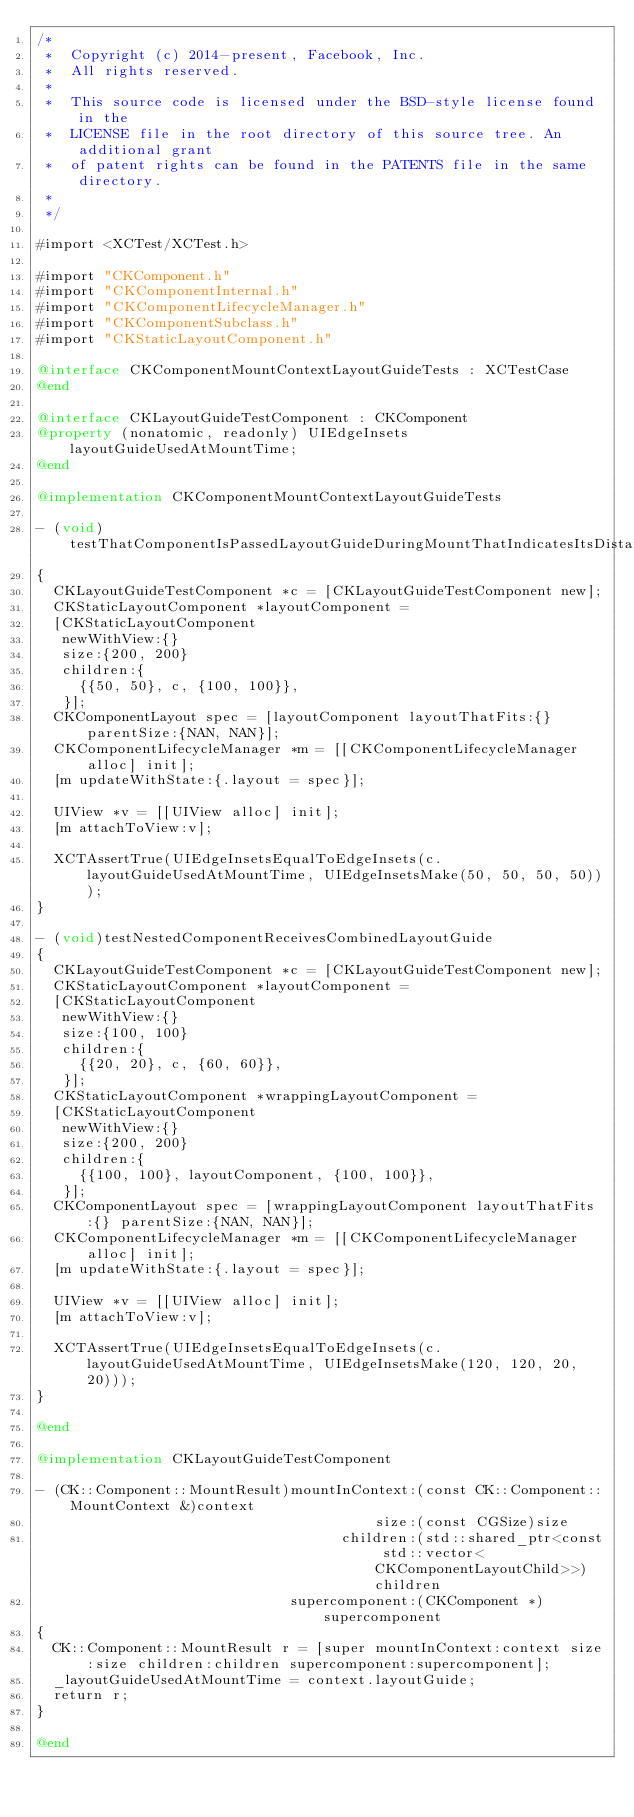<code> <loc_0><loc_0><loc_500><loc_500><_ObjectiveC_>/*
 *  Copyright (c) 2014-present, Facebook, Inc.
 *  All rights reserved.
 *
 *  This source code is licensed under the BSD-style license found in the
 *  LICENSE file in the root directory of this source tree. An additional grant 
 *  of patent rights can be found in the PATENTS file in the same directory.
 *
 */

#import <XCTest/XCTest.h>

#import "CKComponent.h"
#import "CKComponentInternal.h"
#import "CKComponentLifecycleManager.h"
#import "CKComponentSubclass.h"
#import "CKStaticLayoutComponent.h"

@interface CKComponentMountContextLayoutGuideTests : XCTestCase
@end

@interface CKLayoutGuideTestComponent : CKComponent
@property (nonatomic, readonly) UIEdgeInsets layoutGuideUsedAtMountTime;
@end

@implementation CKComponentMountContextLayoutGuideTests

- (void)testThatComponentIsPassedLayoutGuideDuringMountThatIndicatesItsDistanceFromRootComponentEdges
{
  CKLayoutGuideTestComponent *c = [CKLayoutGuideTestComponent new];
  CKStaticLayoutComponent *layoutComponent =
  [CKStaticLayoutComponent
   newWithView:{}
   size:{200, 200}
   children:{
     {{50, 50}, c, {100, 100}},
   }];
  CKComponentLayout spec = [layoutComponent layoutThatFits:{} parentSize:{NAN, NAN}];
  CKComponentLifecycleManager *m = [[CKComponentLifecycleManager alloc] init];
  [m updateWithState:{.layout = spec}];

  UIView *v = [[UIView alloc] init];
  [m attachToView:v];

  XCTAssertTrue(UIEdgeInsetsEqualToEdgeInsets(c.layoutGuideUsedAtMountTime, UIEdgeInsetsMake(50, 50, 50, 50)));
}

- (void)testNestedComponentReceivesCombinedLayoutGuide
{
  CKLayoutGuideTestComponent *c = [CKLayoutGuideTestComponent new];
  CKStaticLayoutComponent *layoutComponent =
  [CKStaticLayoutComponent
   newWithView:{}
   size:{100, 100}
   children:{
     {{20, 20}, c, {60, 60}},
   }];
  CKStaticLayoutComponent *wrappingLayoutComponent =
  [CKStaticLayoutComponent
   newWithView:{}
   size:{200, 200}
   children:{
     {{100, 100}, layoutComponent, {100, 100}},
   }];
  CKComponentLayout spec = [wrappingLayoutComponent layoutThatFits:{} parentSize:{NAN, NAN}];
  CKComponentLifecycleManager *m = [[CKComponentLifecycleManager alloc] init];
  [m updateWithState:{.layout = spec}];

  UIView *v = [[UIView alloc] init];
  [m attachToView:v];

  XCTAssertTrue(UIEdgeInsetsEqualToEdgeInsets(c.layoutGuideUsedAtMountTime, UIEdgeInsetsMake(120, 120, 20, 20)));
}

@end

@implementation CKLayoutGuideTestComponent

- (CK::Component::MountResult)mountInContext:(const CK::Component::MountContext &)context
                                        size:(const CGSize)size
                                    children:(std::shared_ptr<const std::vector<CKComponentLayoutChild>>)children
                              supercomponent:(CKComponent *)supercomponent
{
  CK::Component::MountResult r = [super mountInContext:context size:size children:children supercomponent:supercomponent];
  _layoutGuideUsedAtMountTime = context.layoutGuide;
  return r;
}

@end
</code> 